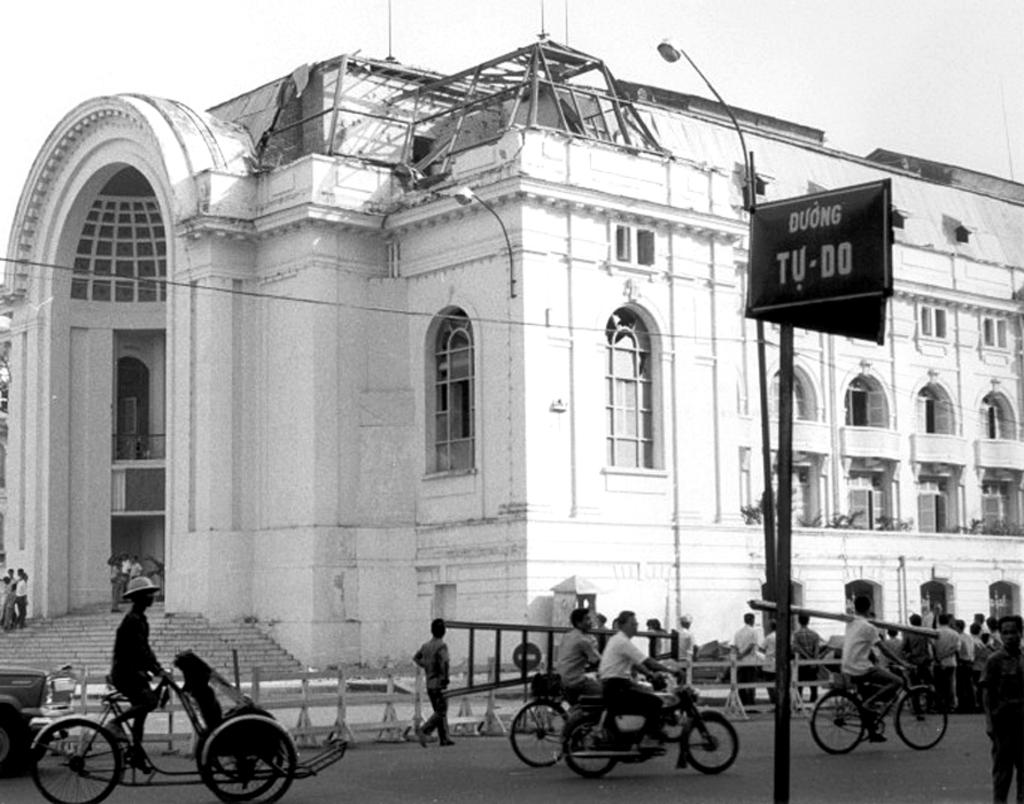What type of structure is present in the image? There is a building in the image. What are the people in the image doing? People are riding vehicles in the image. Can you identify any street fixtures in the image? Yes, there is a street light in the image. Are there any persons not riding vehicles in the image? Yes, some persons are standing on the road in the image. What type of grass is growing on the roof of the building in the image? There is no grass visible on the roof of the building in the image. What is the value of the frog sitting on the street light in the image? There is no frog present in the image, so it is not possible to determine its value. 